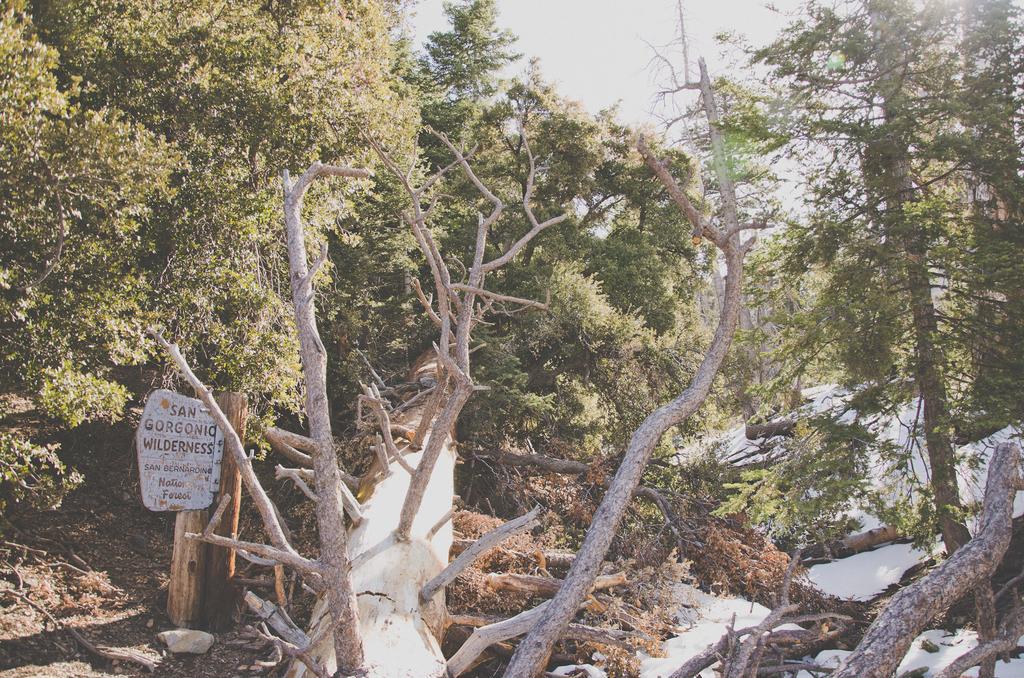Can you describe this image briefly? In the image we can see wooden log, trees and the sky. We can even see the snowboard and text on the board. 